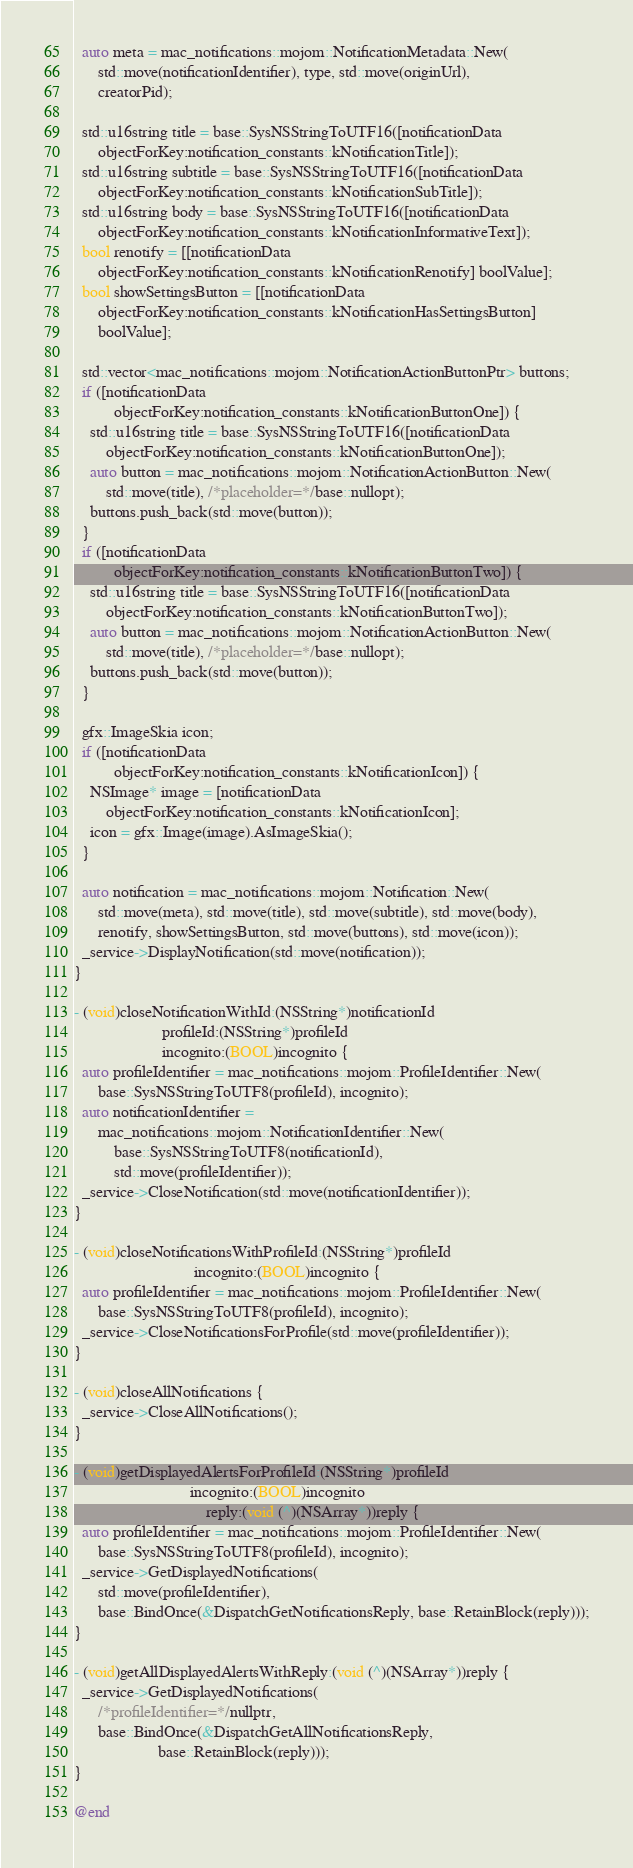<code> <loc_0><loc_0><loc_500><loc_500><_ObjectiveC_>
  auto meta = mac_notifications::mojom::NotificationMetadata::New(
      std::move(notificationIdentifier), type, std::move(originUrl),
      creatorPid);

  std::u16string title = base::SysNSStringToUTF16([notificationData
      objectForKey:notification_constants::kNotificationTitle]);
  std::u16string subtitle = base::SysNSStringToUTF16([notificationData
      objectForKey:notification_constants::kNotificationSubTitle]);
  std::u16string body = base::SysNSStringToUTF16([notificationData
      objectForKey:notification_constants::kNotificationInformativeText]);
  bool renotify = [[notificationData
      objectForKey:notification_constants::kNotificationRenotify] boolValue];
  bool showSettingsButton = [[notificationData
      objectForKey:notification_constants::kNotificationHasSettingsButton]
      boolValue];

  std::vector<mac_notifications::mojom::NotificationActionButtonPtr> buttons;
  if ([notificationData
          objectForKey:notification_constants::kNotificationButtonOne]) {
    std::u16string title = base::SysNSStringToUTF16([notificationData
        objectForKey:notification_constants::kNotificationButtonOne]);
    auto button = mac_notifications::mojom::NotificationActionButton::New(
        std::move(title), /*placeholder=*/base::nullopt);
    buttons.push_back(std::move(button));
  }
  if ([notificationData
          objectForKey:notification_constants::kNotificationButtonTwo]) {
    std::u16string title = base::SysNSStringToUTF16([notificationData
        objectForKey:notification_constants::kNotificationButtonTwo]);
    auto button = mac_notifications::mojom::NotificationActionButton::New(
        std::move(title), /*placeholder=*/base::nullopt);
    buttons.push_back(std::move(button));
  }

  gfx::ImageSkia icon;
  if ([notificationData
          objectForKey:notification_constants::kNotificationIcon]) {
    NSImage* image = [notificationData
        objectForKey:notification_constants::kNotificationIcon];
    icon = gfx::Image(image).AsImageSkia();
  }

  auto notification = mac_notifications::mojom::Notification::New(
      std::move(meta), std::move(title), std::move(subtitle), std::move(body),
      renotify, showSettingsButton, std::move(buttons), std::move(icon));
  _service->DisplayNotification(std::move(notification));
}

- (void)closeNotificationWithId:(NSString*)notificationId
                      profileId:(NSString*)profileId
                      incognito:(BOOL)incognito {
  auto profileIdentifier = mac_notifications::mojom::ProfileIdentifier::New(
      base::SysNSStringToUTF8(profileId), incognito);
  auto notificationIdentifier =
      mac_notifications::mojom::NotificationIdentifier::New(
          base::SysNSStringToUTF8(notificationId),
          std::move(profileIdentifier));
  _service->CloseNotification(std::move(notificationIdentifier));
}

- (void)closeNotificationsWithProfileId:(NSString*)profileId
                              incognito:(BOOL)incognito {
  auto profileIdentifier = mac_notifications::mojom::ProfileIdentifier::New(
      base::SysNSStringToUTF8(profileId), incognito);
  _service->CloseNotificationsForProfile(std::move(profileIdentifier));
}

- (void)closeAllNotifications {
  _service->CloseAllNotifications();
}

- (void)getDisplayedAlertsForProfileId:(NSString*)profileId
                             incognito:(BOOL)incognito
                                 reply:(void (^)(NSArray*))reply {
  auto profileIdentifier = mac_notifications::mojom::ProfileIdentifier::New(
      base::SysNSStringToUTF8(profileId), incognito);
  _service->GetDisplayedNotifications(
      std::move(profileIdentifier),
      base::BindOnce(&DispatchGetNotificationsReply, base::RetainBlock(reply)));
}

- (void)getAllDisplayedAlertsWithReply:(void (^)(NSArray*))reply {
  _service->GetDisplayedNotifications(
      /*profileIdentifier=*/nullptr,
      base::BindOnce(&DispatchGetAllNotificationsReply,
                     base::RetainBlock(reply)));
}

@end
</code> 